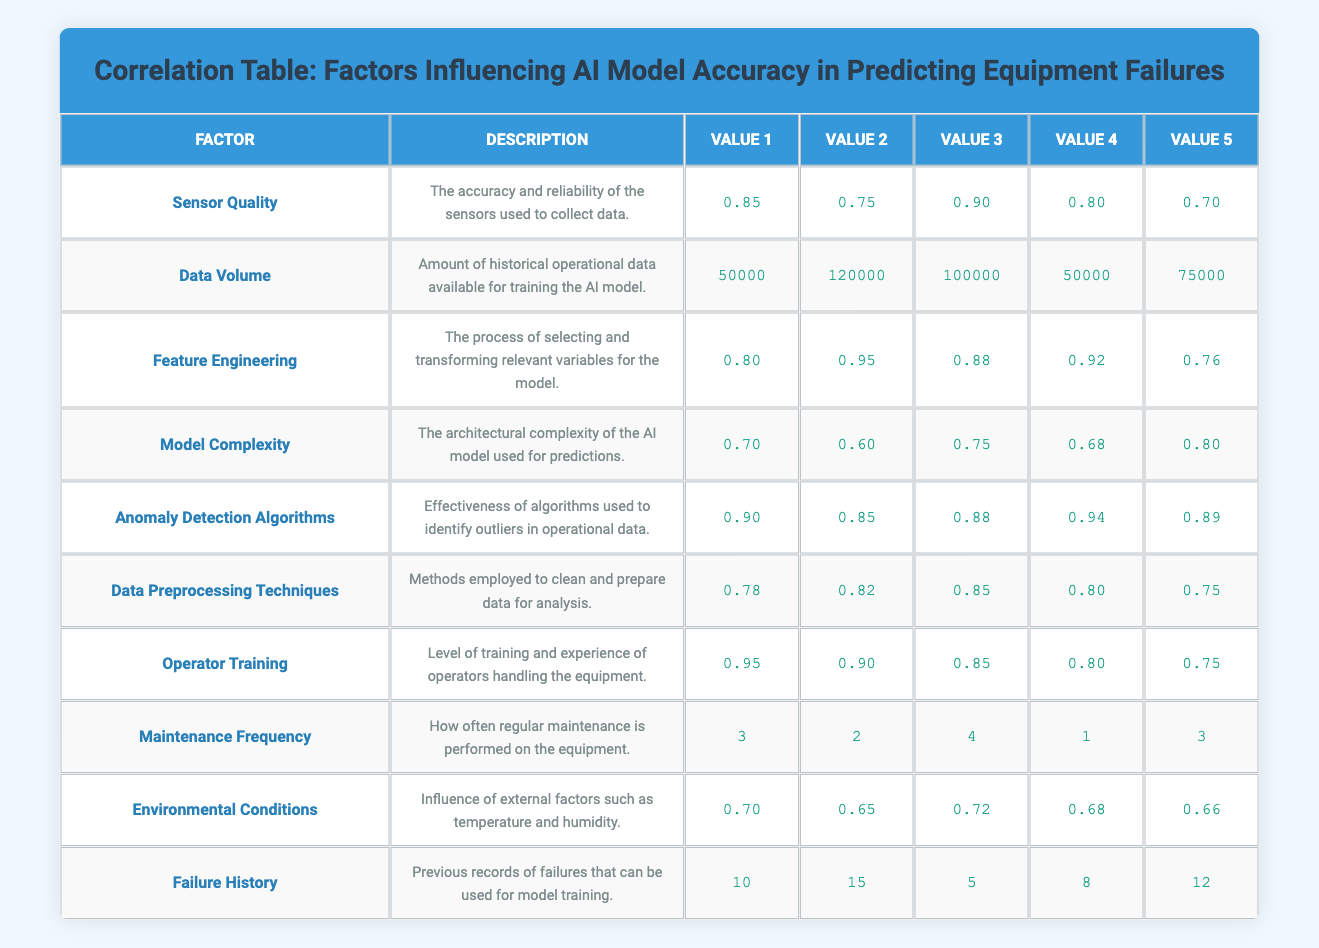What is the value of Sensor Quality? The table lists the values for Sensor Quality as 0.85, 0.75, 0.90, 0.80, and 0.70. The first value we see for Sensor Quality is 0.85.
Answer: 0.85 What is the average value of Maintenance Frequency? To find the average, add the values (3 + 2 + 4 + 1 + 3) = 13 and then divide by the number of values, which is 5. Therefore, 13/5 = 2.6.
Answer: 2.6 Is the average value of Data Volume greater than 80000? First, we calculate the average by summing the values (50000 + 120000 + 100000 + 50000 + 75000 = 400000) and dividing by 5, which gives us an average of 80000. Since 80000 is not greater than itself, the answer is no.
Answer: No Which factor has the highest value in the last row (Failure History)? The values in the last row are 10, 15, 5, 8, and 12. The highest value among these is 15.
Answer: 15 What is the difference between the highest and lowest value of Feature Engineering? The values for Feature Engineering are 0.80, 0.95, 0.88, 0.92, and 0.76. The highest is 0.95 and the lowest is 0.76. The difference is 0.95 - 0.76 = 0.19.
Answer: 0.19 Which factor has the lowest value in the column for Value 4? Looking at the fourth column, the values are 0.80, 50000, 0.92, 0.68, 0.94, 0.80, 0.80, 1, 0.68, and 8. The lowest value is 1 (from Maintenance Frequency).
Answer: 1 If we consider only the first values of each factor, what is the cumulative sum? The first values are 0.85, 50000, 0.80, 0.70, 0.90, 0.78, 0.95, 3, 0.70, and 10. Sum them up: 0.85 + 50000 + 0.80 + 0.70 + 0.90 + 0.78 + 0.95 + 3 + 0.70 + 10 = 50018.
Answer: 50018 Does Operator Training have a value that is the highest compared to all factors? From the Operator Training values (0.95, 0.90, 0.85, 0.80, 0.75), the highest is 0.95, which is not the highest overall since Anomaly Detection Algorithms' highest value is 0.94.
Answer: No 